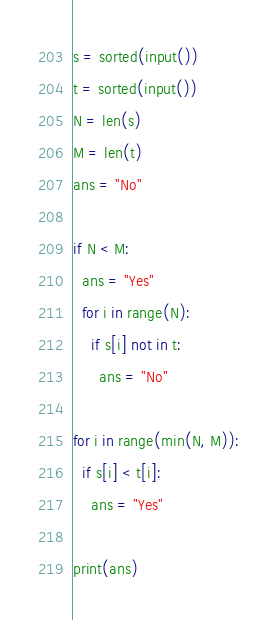<code> <loc_0><loc_0><loc_500><loc_500><_Python_>s = sorted(input())
t = sorted(input())
N = len(s)
M = len(t)
ans = "No"

if N < M:
  ans = "Yes"
  for i in range(N):
    if s[i] not in t:
      ans = "No"

for i in range(min(N, M)):
  if s[i] < t[i]:
    ans = "Yes"

print(ans)
</code> 